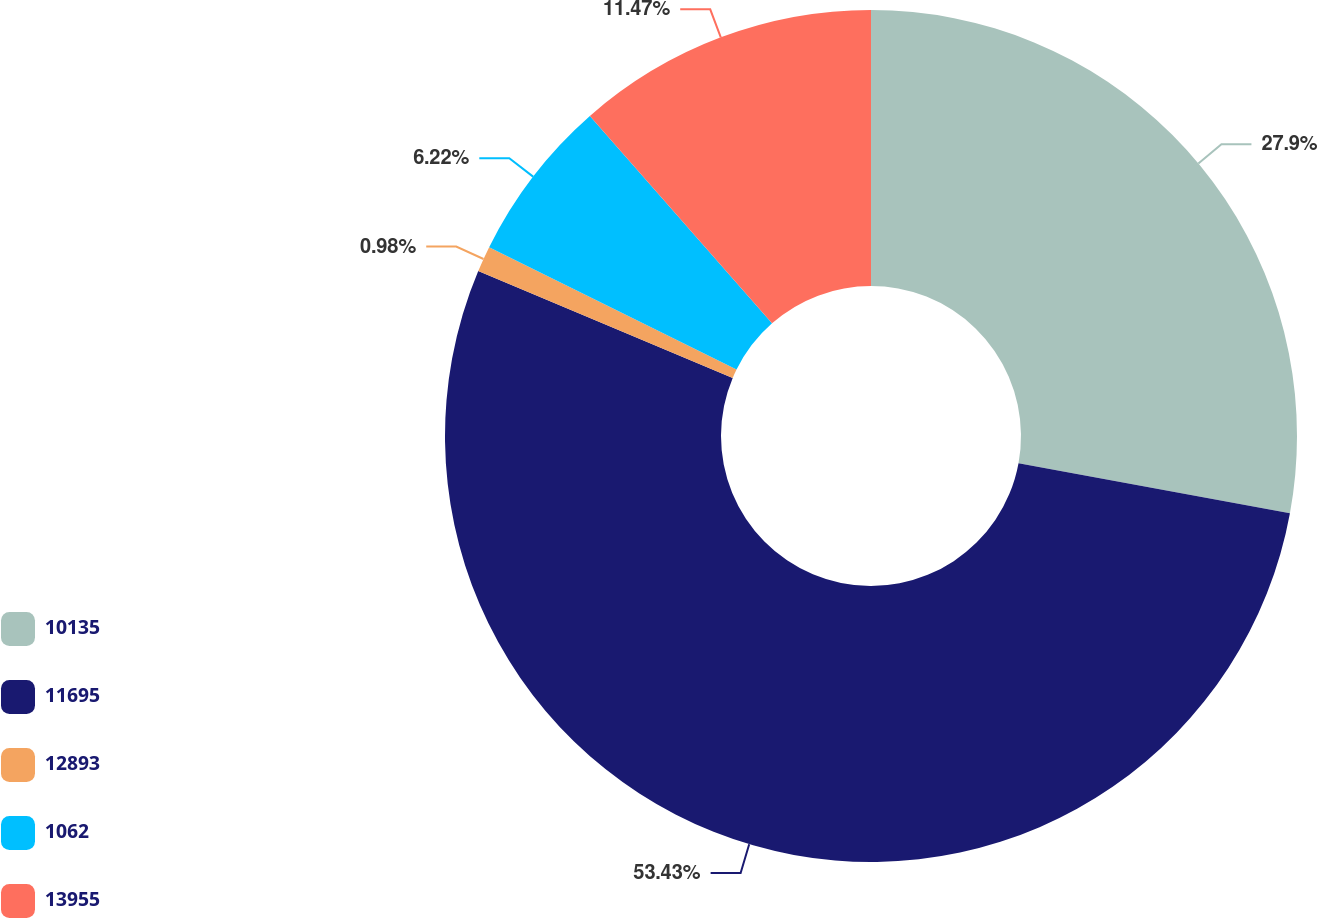Convert chart to OTSL. <chart><loc_0><loc_0><loc_500><loc_500><pie_chart><fcel>10135<fcel>11695<fcel>12893<fcel>1062<fcel>13955<nl><fcel>27.9%<fcel>53.43%<fcel>0.98%<fcel>6.22%<fcel>11.47%<nl></chart> 